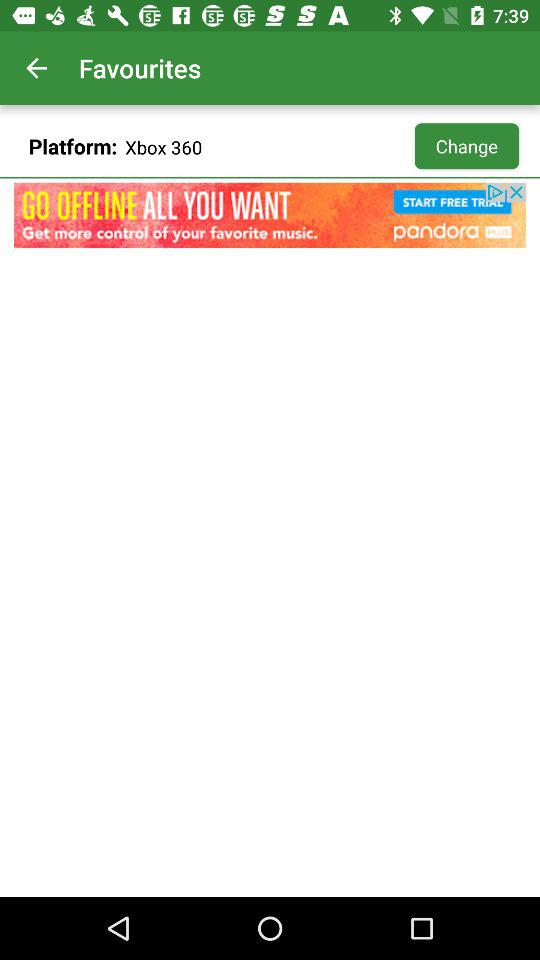What is the platform? The platform is "Xbox 360". 